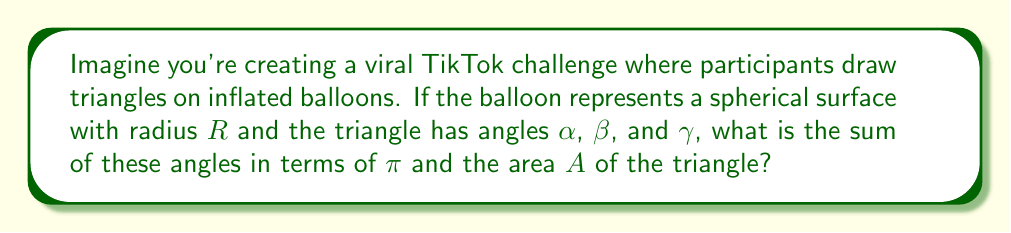Could you help me with this problem? Let's approach this step-by-step:

1) In spherical geometry, the sum of angles in a triangle is greater than $\pi$ radians (180°). The excess is related to the area of the triangle.

2) The formula for the angle sum in a spherical triangle is:

   $$\alpha + \beta + \gamma = \pi + \frac{A}{R^2}$$

   Where $A$ is the area of the triangle and $R$ is the radius of the sphere.

3) To express this in terms of $\pi$ and $A$, we need to factor out $\pi$:

   $$\alpha + \beta + \gamma = \pi (1 + \frac{A}{\pi R^2})$$

4) The term $\frac{A}{\pi R^2}$ represents the fraction of the sphere's surface area occupied by the triangle.

5) This formula shows that as the area of the triangle increases, the sum of its angles also increases above $\pi$.

[asy]
import geometry;

size(200);
pair O=(0,0);
real R=5;
draw(circle(O,R));
pair A=R*dir(60);
pair B=R*dir(180);
pair C=R*dir(300);
draw(A--B--C--cycle);
label("A",A,NE);
label("B",B,W);
label("C",C,SE);
label("O",O,S);
draw(O--A,dashed);
draw(O--B,dashed);
draw(O--C,dashed);
[/asy]
Answer: $\pi (1 + \frac{A}{\pi R^2})$ 